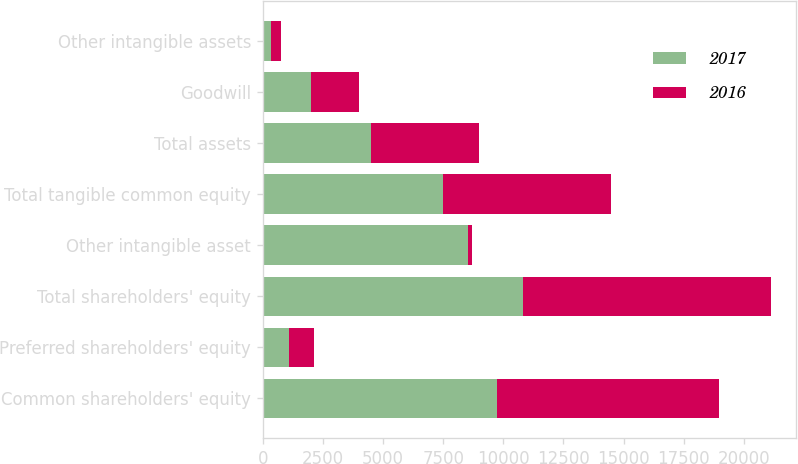Convert chart. <chart><loc_0><loc_0><loc_500><loc_500><stacked_bar_chart><ecel><fcel>Common shareholders' equity<fcel>Preferred shareholders' equity<fcel>Total shareholders' equity<fcel>Other intangible asset<fcel>Total tangible common equity<fcel>Total assets<fcel>Goodwill<fcel>Other intangible assets<nl><fcel>2017<fcel>9743<fcel>1071<fcel>10814<fcel>8548<fcel>7477<fcel>4488<fcel>1993<fcel>346<nl><fcel>2016<fcel>9237<fcel>1071<fcel>10308<fcel>141<fcel>6983<fcel>4488<fcel>1993<fcel>402<nl></chart> 